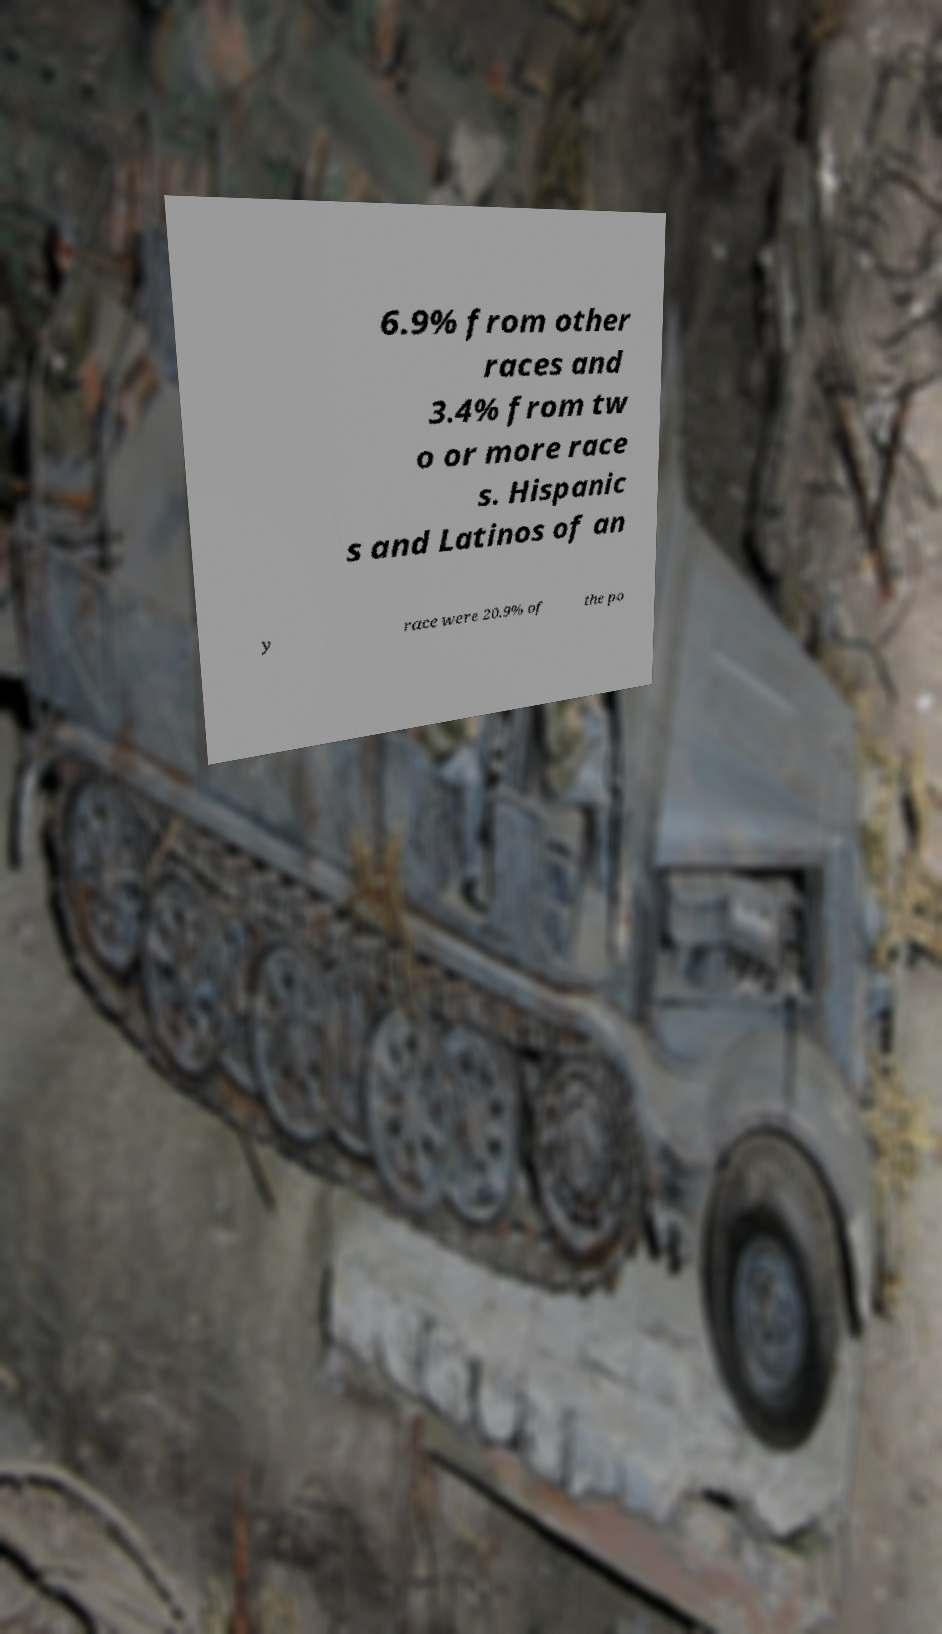For documentation purposes, I need the text within this image transcribed. Could you provide that? 6.9% from other races and 3.4% from tw o or more race s. Hispanic s and Latinos of an y race were 20.9% of the po 